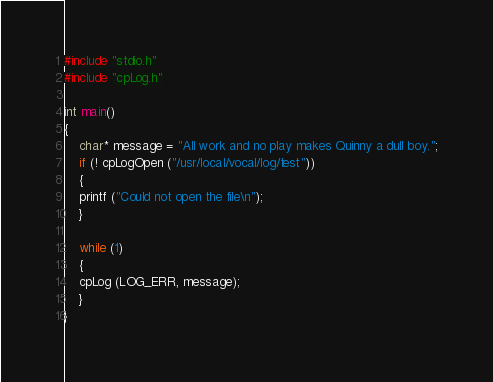Convert code to text. <code><loc_0><loc_0><loc_500><loc_500><_C++_>#include "stdio.h"
#include "cpLog.h"

int main()
{
    char* message = "All work and no play makes Quinny a dull boy.";
    if (! cpLogOpen ("/usr/local/vocal/log/test"))
    {
	printf ("Could not open the file\n");
    }

    while (1)
    {
	cpLog (LOG_ERR, message);
    }
}
</code> 